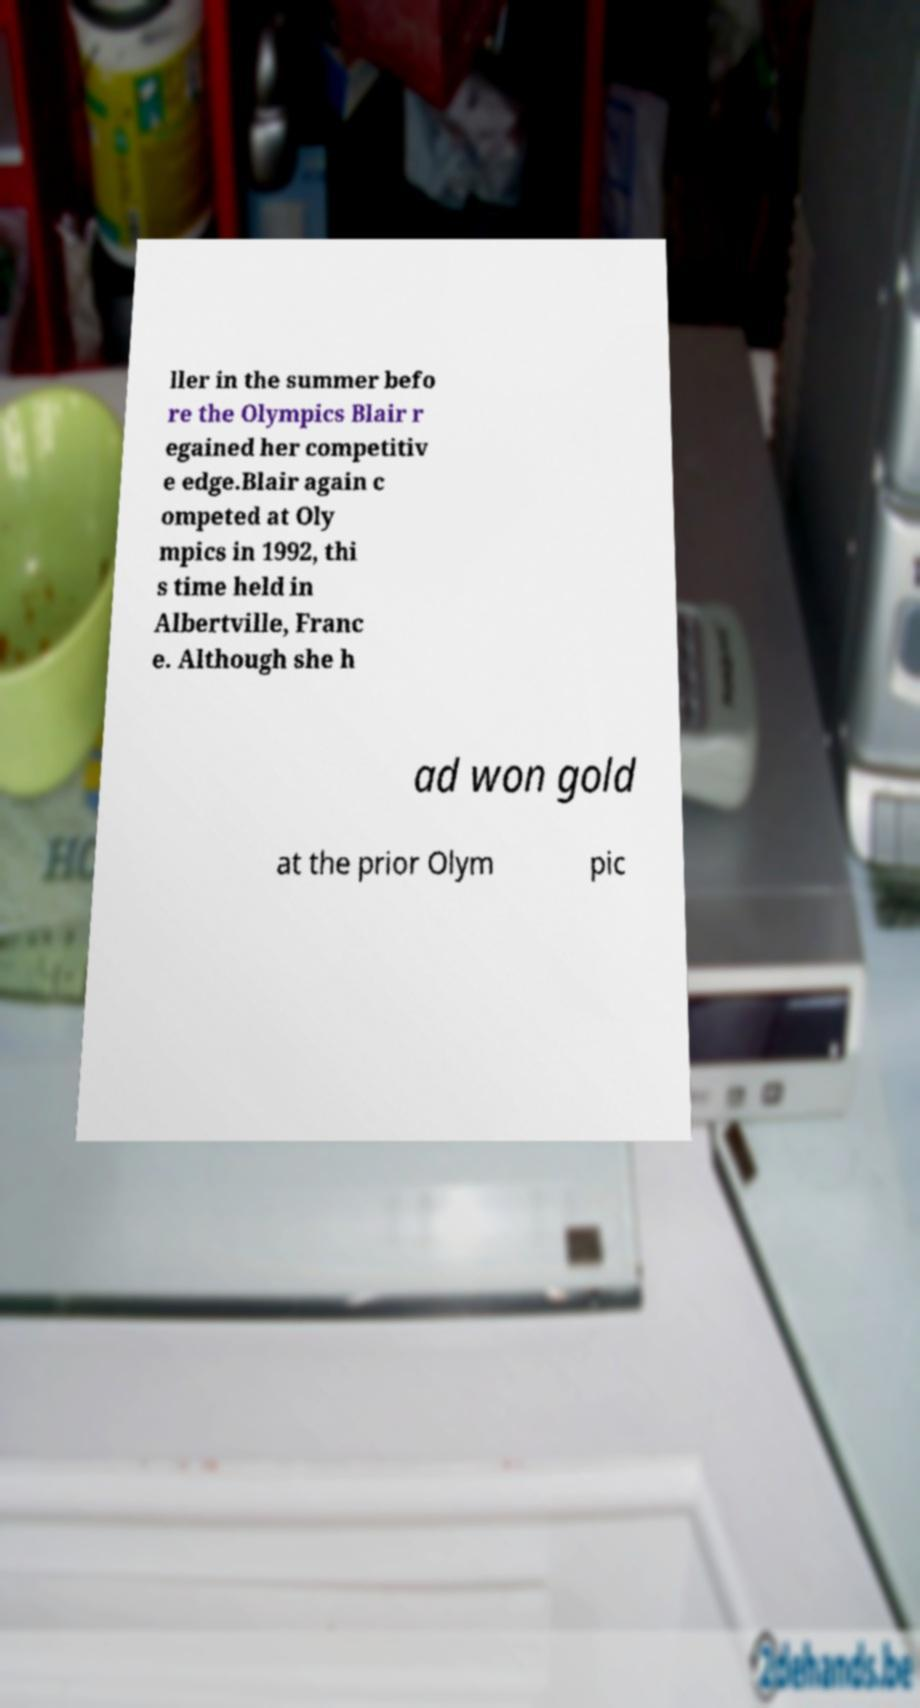What messages or text are displayed in this image? I need them in a readable, typed format. ller in the summer befo re the Olympics Blair r egained her competitiv e edge.Blair again c ompeted at Oly mpics in 1992, thi s time held in Albertville, Franc e. Although she h ad won gold at the prior Olym pic 